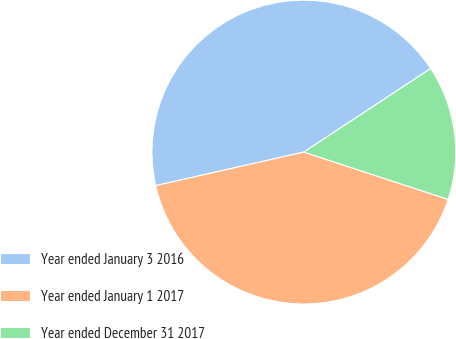<chart> <loc_0><loc_0><loc_500><loc_500><pie_chart><fcel>Year ended January 3 2016<fcel>Year ended January 1 2017<fcel>Year ended December 31 2017<nl><fcel>44.28%<fcel>41.41%<fcel>14.31%<nl></chart> 